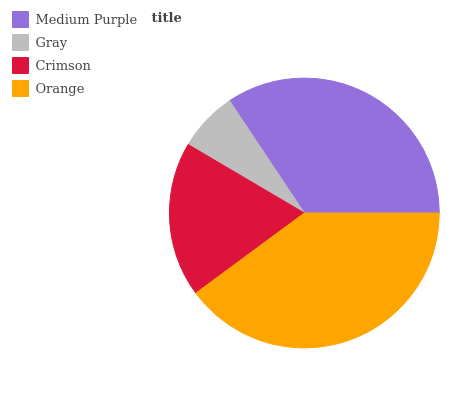Is Gray the minimum?
Answer yes or no. Yes. Is Orange the maximum?
Answer yes or no. Yes. Is Crimson the minimum?
Answer yes or no. No. Is Crimson the maximum?
Answer yes or no. No. Is Crimson greater than Gray?
Answer yes or no. Yes. Is Gray less than Crimson?
Answer yes or no. Yes. Is Gray greater than Crimson?
Answer yes or no. No. Is Crimson less than Gray?
Answer yes or no. No. Is Medium Purple the high median?
Answer yes or no. Yes. Is Crimson the low median?
Answer yes or no. Yes. Is Crimson the high median?
Answer yes or no. No. Is Medium Purple the low median?
Answer yes or no. No. 